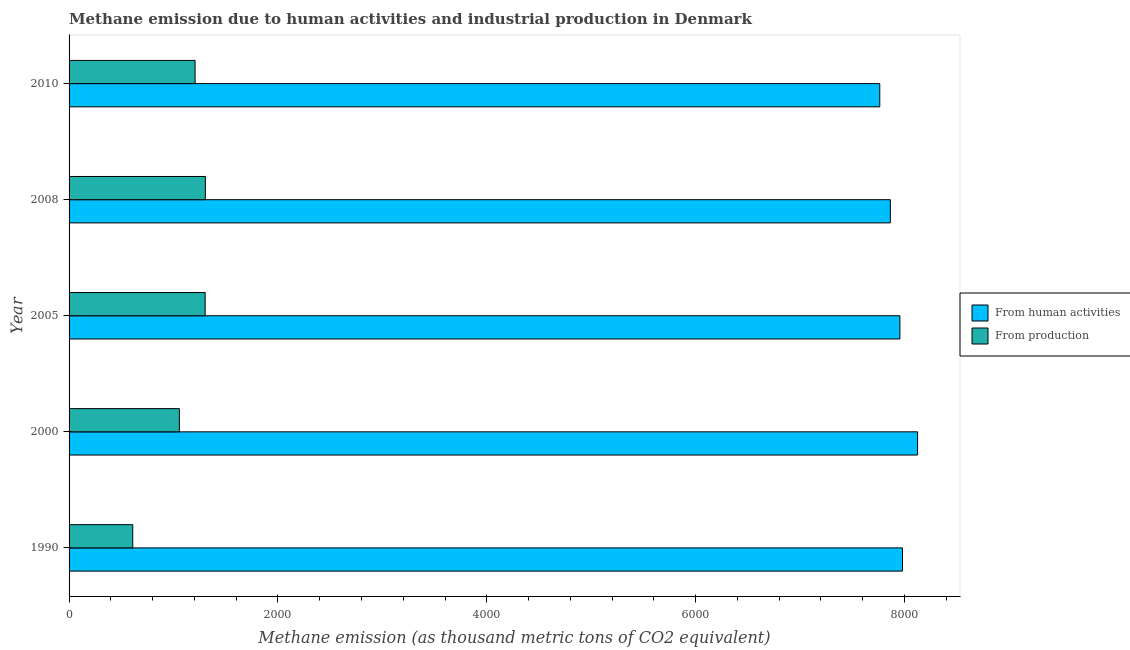Are the number of bars per tick equal to the number of legend labels?
Provide a short and direct response. Yes. How many bars are there on the 2nd tick from the bottom?
Offer a terse response. 2. What is the label of the 3rd group of bars from the top?
Ensure brevity in your answer.  2005. What is the amount of emissions from human activities in 2010?
Your answer should be compact. 7762.9. Across all years, what is the maximum amount of emissions from human activities?
Give a very brief answer. 8124.9. Across all years, what is the minimum amount of emissions from human activities?
Provide a short and direct response. 7762.9. In which year was the amount of emissions generated from industries maximum?
Your answer should be very brief. 2008. What is the total amount of emissions from human activities in the graph?
Make the answer very short. 3.97e+04. What is the difference between the amount of emissions from human activities in 1990 and that in 2010?
Provide a short and direct response. 217.6. What is the difference between the amount of emissions from human activities in 2000 and the amount of emissions generated from industries in 2008?
Keep it short and to the point. 6820. What is the average amount of emissions generated from industries per year?
Provide a short and direct response. 1096.1. In the year 1990, what is the difference between the amount of emissions from human activities and amount of emissions generated from industries?
Provide a short and direct response. 7370.8. Is the amount of emissions from human activities in 1990 less than that in 2008?
Keep it short and to the point. No. Is the difference between the amount of emissions generated from industries in 1990 and 2010 greater than the difference between the amount of emissions from human activities in 1990 and 2010?
Make the answer very short. No. What is the difference between the highest and the second highest amount of emissions from human activities?
Offer a very short reply. 144.4. What is the difference between the highest and the lowest amount of emissions from human activities?
Keep it short and to the point. 362. In how many years, is the amount of emissions from human activities greater than the average amount of emissions from human activities taken over all years?
Offer a terse response. 3. Is the sum of the amount of emissions from human activities in 1990 and 2010 greater than the maximum amount of emissions generated from industries across all years?
Make the answer very short. Yes. What does the 2nd bar from the top in 2008 represents?
Offer a terse response. From human activities. What does the 1st bar from the bottom in 1990 represents?
Provide a succinct answer. From human activities. How many bars are there?
Offer a terse response. 10. How many years are there in the graph?
Provide a succinct answer. 5. Are the values on the major ticks of X-axis written in scientific E-notation?
Ensure brevity in your answer.  No. Does the graph contain any zero values?
Provide a short and direct response. No. Does the graph contain grids?
Your answer should be very brief. No. How many legend labels are there?
Keep it short and to the point. 2. What is the title of the graph?
Offer a terse response. Methane emission due to human activities and industrial production in Denmark. What is the label or title of the X-axis?
Provide a succinct answer. Methane emission (as thousand metric tons of CO2 equivalent). What is the label or title of the Y-axis?
Ensure brevity in your answer.  Year. What is the Methane emission (as thousand metric tons of CO2 equivalent) in From human activities in 1990?
Your answer should be compact. 7980.5. What is the Methane emission (as thousand metric tons of CO2 equivalent) of From production in 1990?
Make the answer very short. 609.7. What is the Methane emission (as thousand metric tons of CO2 equivalent) in From human activities in 2000?
Your response must be concise. 8124.9. What is the Methane emission (as thousand metric tons of CO2 equivalent) in From production in 2000?
Your answer should be compact. 1056. What is the Methane emission (as thousand metric tons of CO2 equivalent) of From human activities in 2005?
Your response must be concise. 7955.5. What is the Methane emission (as thousand metric tons of CO2 equivalent) in From production in 2005?
Your response must be concise. 1303.1. What is the Methane emission (as thousand metric tons of CO2 equivalent) in From human activities in 2008?
Ensure brevity in your answer.  7864.1. What is the Methane emission (as thousand metric tons of CO2 equivalent) in From production in 2008?
Provide a short and direct response. 1304.9. What is the Methane emission (as thousand metric tons of CO2 equivalent) in From human activities in 2010?
Give a very brief answer. 7762.9. What is the Methane emission (as thousand metric tons of CO2 equivalent) of From production in 2010?
Offer a terse response. 1206.8. Across all years, what is the maximum Methane emission (as thousand metric tons of CO2 equivalent) in From human activities?
Provide a succinct answer. 8124.9. Across all years, what is the maximum Methane emission (as thousand metric tons of CO2 equivalent) in From production?
Offer a terse response. 1304.9. Across all years, what is the minimum Methane emission (as thousand metric tons of CO2 equivalent) of From human activities?
Keep it short and to the point. 7762.9. Across all years, what is the minimum Methane emission (as thousand metric tons of CO2 equivalent) of From production?
Your response must be concise. 609.7. What is the total Methane emission (as thousand metric tons of CO2 equivalent) of From human activities in the graph?
Your answer should be compact. 3.97e+04. What is the total Methane emission (as thousand metric tons of CO2 equivalent) in From production in the graph?
Offer a very short reply. 5480.5. What is the difference between the Methane emission (as thousand metric tons of CO2 equivalent) of From human activities in 1990 and that in 2000?
Provide a short and direct response. -144.4. What is the difference between the Methane emission (as thousand metric tons of CO2 equivalent) of From production in 1990 and that in 2000?
Provide a succinct answer. -446.3. What is the difference between the Methane emission (as thousand metric tons of CO2 equivalent) of From production in 1990 and that in 2005?
Offer a very short reply. -693.4. What is the difference between the Methane emission (as thousand metric tons of CO2 equivalent) of From human activities in 1990 and that in 2008?
Make the answer very short. 116.4. What is the difference between the Methane emission (as thousand metric tons of CO2 equivalent) of From production in 1990 and that in 2008?
Give a very brief answer. -695.2. What is the difference between the Methane emission (as thousand metric tons of CO2 equivalent) in From human activities in 1990 and that in 2010?
Provide a short and direct response. 217.6. What is the difference between the Methane emission (as thousand metric tons of CO2 equivalent) of From production in 1990 and that in 2010?
Your answer should be very brief. -597.1. What is the difference between the Methane emission (as thousand metric tons of CO2 equivalent) of From human activities in 2000 and that in 2005?
Your response must be concise. 169.4. What is the difference between the Methane emission (as thousand metric tons of CO2 equivalent) of From production in 2000 and that in 2005?
Provide a succinct answer. -247.1. What is the difference between the Methane emission (as thousand metric tons of CO2 equivalent) in From human activities in 2000 and that in 2008?
Your answer should be compact. 260.8. What is the difference between the Methane emission (as thousand metric tons of CO2 equivalent) of From production in 2000 and that in 2008?
Your answer should be very brief. -248.9. What is the difference between the Methane emission (as thousand metric tons of CO2 equivalent) in From human activities in 2000 and that in 2010?
Ensure brevity in your answer.  362. What is the difference between the Methane emission (as thousand metric tons of CO2 equivalent) in From production in 2000 and that in 2010?
Offer a very short reply. -150.8. What is the difference between the Methane emission (as thousand metric tons of CO2 equivalent) of From human activities in 2005 and that in 2008?
Offer a very short reply. 91.4. What is the difference between the Methane emission (as thousand metric tons of CO2 equivalent) of From human activities in 2005 and that in 2010?
Offer a very short reply. 192.6. What is the difference between the Methane emission (as thousand metric tons of CO2 equivalent) in From production in 2005 and that in 2010?
Provide a short and direct response. 96.3. What is the difference between the Methane emission (as thousand metric tons of CO2 equivalent) in From human activities in 2008 and that in 2010?
Make the answer very short. 101.2. What is the difference between the Methane emission (as thousand metric tons of CO2 equivalent) of From production in 2008 and that in 2010?
Provide a short and direct response. 98.1. What is the difference between the Methane emission (as thousand metric tons of CO2 equivalent) of From human activities in 1990 and the Methane emission (as thousand metric tons of CO2 equivalent) of From production in 2000?
Keep it short and to the point. 6924.5. What is the difference between the Methane emission (as thousand metric tons of CO2 equivalent) of From human activities in 1990 and the Methane emission (as thousand metric tons of CO2 equivalent) of From production in 2005?
Keep it short and to the point. 6677.4. What is the difference between the Methane emission (as thousand metric tons of CO2 equivalent) of From human activities in 1990 and the Methane emission (as thousand metric tons of CO2 equivalent) of From production in 2008?
Ensure brevity in your answer.  6675.6. What is the difference between the Methane emission (as thousand metric tons of CO2 equivalent) of From human activities in 1990 and the Methane emission (as thousand metric tons of CO2 equivalent) of From production in 2010?
Your answer should be very brief. 6773.7. What is the difference between the Methane emission (as thousand metric tons of CO2 equivalent) of From human activities in 2000 and the Methane emission (as thousand metric tons of CO2 equivalent) of From production in 2005?
Give a very brief answer. 6821.8. What is the difference between the Methane emission (as thousand metric tons of CO2 equivalent) in From human activities in 2000 and the Methane emission (as thousand metric tons of CO2 equivalent) in From production in 2008?
Your response must be concise. 6820. What is the difference between the Methane emission (as thousand metric tons of CO2 equivalent) of From human activities in 2000 and the Methane emission (as thousand metric tons of CO2 equivalent) of From production in 2010?
Your answer should be compact. 6918.1. What is the difference between the Methane emission (as thousand metric tons of CO2 equivalent) in From human activities in 2005 and the Methane emission (as thousand metric tons of CO2 equivalent) in From production in 2008?
Make the answer very short. 6650.6. What is the difference between the Methane emission (as thousand metric tons of CO2 equivalent) in From human activities in 2005 and the Methane emission (as thousand metric tons of CO2 equivalent) in From production in 2010?
Ensure brevity in your answer.  6748.7. What is the difference between the Methane emission (as thousand metric tons of CO2 equivalent) of From human activities in 2008 and the Methane emission (as thousand metric tons of CO2 equivalent) of From production in 2010?
Offer a very short reply. 6657.3. What is the average Methane emission (as thousand metric tons of CO2 equivalent) of From human activities per year?
Keep it short and to the point. 7937.58. What is the average Methane emission (as thousand metric tons of CO2 equivalent) of From production per year?
Offer a very short reply. 1096.1. In the year 1990, what is the difference between the Methane emission (as thousand metric tons of CO2 equivalent) in From human activities and Methane emission (as thousand metric tons of CO2 equivalent) in From production?
Provide a succinct answer. 7370.8. In the year 2000, what is the difference between the Methane emission (as thousand metric tons of CO2 equivalent) in From human activities and Methane emission (as thousand metric tons of CO2 equivalent) in From production?
Your response must be concise. 7068.9. In the year 2005, what is the difference between the Methane emission (as thousand metric tons of CO2 equivalent) of From human activities and Methane emission (as thousand metric tons of CO2 equivalent) of From production?
Your response must be concise. 6652.4. In the year 2008, what is the difference between the Methane emission (as thousand metric tons of CO2 equivalent) in From human activities and Methane emission (as thousand metric tons of CO2 equivalent) in From production?
Your answer should be very brief. 6559.2. In the year 2010, what is the difference between the Methane emission (as thousand metric tons of CO2 equivalent) of From human activities and Methane emission (as thousand metric tons of CO2 equivalent) of From production?
Give a very brief answer. 6556.1. What is the ratio of the Methane emission (as thousand metric tons of CO2 equivalent) of From human activities in 1990 to that in 2000?
Your answer should be very brief. 0.98. What is the ratio of the Methane emission (as thousand metric tons of CO2 equivalent) of From production in 1990 to that in 2000?
Your answer should be very brief. 0.58. What is the ratio of the Methane emission (as thousand metric tons of CO2 equivalent) in From production in 1990 to that in 2005?
Your answer should be compact. 0.47. What is the ratio of the Methane emission (as thousand metric tons of CO2 equivalent) of From human activities in 1990 to that in 2008?
Your response must be concise. 1.01. What is the ratio of the Methane emission (as thousand metric tons of CO2 equivalent) of From production in 1990 to that in 2008?
Give a very brief answer. 0.47. What is the ratio of the Methane emission (as thousand metric tons of CO2 equivalent) of From human activities in 1990 to that in 2010?
Your answer should be very brief. 1.03. What is the ratio of the Methane emission (as thousand metric tons of CO2 equivalent) in From production in 1990 to that in 2010?
Provide a succinct answer. 0.51. What is the ratio of the Methane emission (as thousand metric tons of CO2 equivalent) in From human activities in 2000 to that in 2005?
Provide a short and direct response. 1.02. What is the ratio of the Methane emission (as thousand metric tons of CO2 equivalent) of From production in 2000 to that in 2005?
Offer a very short reply. 0.81. What is the ratio of the Methane emission (as thousand metric tons of CO2 equivalent) in From human activities in 2000 to that in 2008?
Offer a terse response. 1.03. What is the ratio of the Methane emission (as thousand metric tons of CO2 equivalent) in From production in 2000 to that in 2008?
Make the answer very short. 0.81. What is the ratio of the Methane emission (as thousand metric tons of CO2 equivalent) in From human activities in 2000 to that in 2010?
Provide a short and direct response. 1.05. What is the ratio of the Methane emission (as thousand metric tons of CO2 equivalent) in From production in 2000 to that in 2010?
Keep it short and to the point. 0.88. What is the ratio of the Methane emission (as thousand metric tons of CO2 equivalent) of From human activities in 2005 to that in 2008?
Give a very brief answer. 1.01. What is the ratio of the Methane emission (as thousand metric tons of CO2 equivalent) in From human activities in 2005 to that in 2010?
Your response must be concise. 1.02. What is the ratio of the Methane emission (as thousand metric tons of CO2 equivalent) of From production in 2005 to that in 2010?
Your answer should be very brief. 1.08. What is the ratio of the Methane emission (as thousand metric tons of CO2 equivalent) of From human activities in 2008 to that in 2010?
Offer a very short reply. 1.01. What is the ratio of the Methane emission (as thousand metric tons of CO2 equivalent) of From production in 2008 to that in 2010?
Your response must be concise. 1.08. What is the difference between the highest and the second highest Methane emission (as thousand metric tons of CO2 equivalent) in From human activities?
Your answer should be very brief. 144.4. What is the difference between the highest and the lowest Methane emission (as thousand metric tons of CO2 equivalent) of From human activities?
Make the answer very short. 362. What is the difference between the highest and the lowest Methane emission (as thousand metric tons of CO2 equivalent) in From production?
Provide a succinct answer. 695.2. 